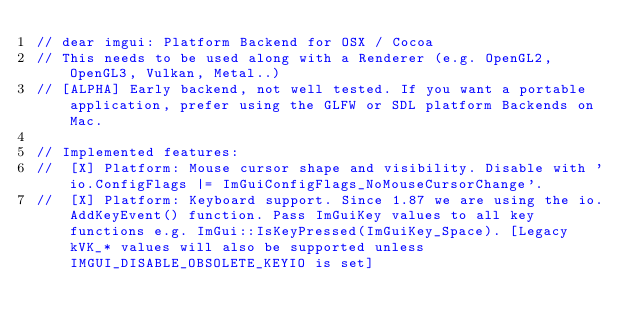Convert code to text. <code><loc_0><loc_0><loc_500><loc_500><_ObjectiveC_>// dear imgui: Platform Backend for OSX / Cocoa
// This needs to be used along with a Renderer (e.g. OpenGL2, OpenGL3, Vulkan, Metal..)
// [ALPHA] Early backend, not well tested. If you want a portable application, prefer using the GLFW or SDL platform Backends on Mac.

// Implemented features:
//  [X] Platform: Mouse cursor shape and visibility. Disable with 'io.ConfigFlags |= ImGuiConfigFlags_NoMouseCursorChange'.
//  [X] Platform: Keyboard support. Since 1.87 we are using the io.AddKeyEvent() function. Pass ImGuiKey values to all key functions e.g. ImGui::IsKeyPressed(ImGuiKey_Space). [Legacy kVK_* values will also be supported unless IMGUI_DISABLE_OBSOLETE_KEYIO is set]</code> 